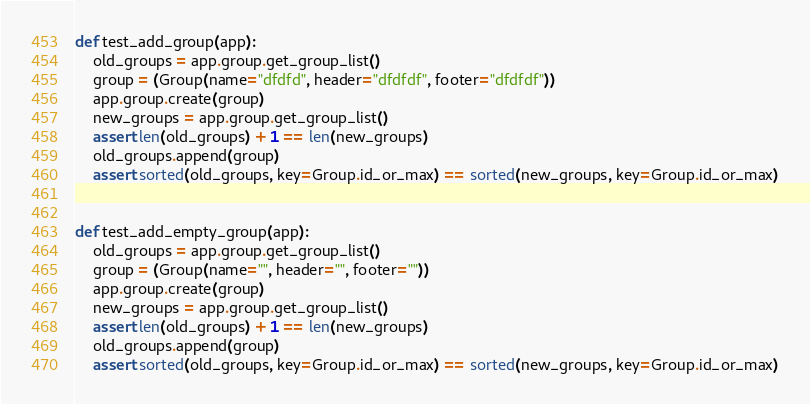<code> <loc_0><loc_0><loc_500><loc_500><_Python_>
def test_add_group(app):
    old_groups = app.group.get_group_list()
    group = (Group(name="dfdfd", header="dfdfdf", footer="dfdfdf"))
    app.group.create(group)
    new_groups = app.group.get_group_list()
    assert len(old_groups) + 1 == len(new_groups)
    old_groups.append(group)
    assert sorted(old_groups, key=Group.id_or_max) == sorted(new_groups, key=Group.id_or_max)


def test_add_empty_group(app):
    old_groups = app.group.get_group_list()
    group = (Group(name="", header="", footer=""))
    app.group.create(group)
    new_groups = app.group.get_group_list()
    assert len(old_groups) + 1 == len(new_groups)
    old_groups.append(group)
    assert sorted(old_groups, key=Group.id_or_max) == sorted(new_groups, key=Group.id_or_max)
</code> 